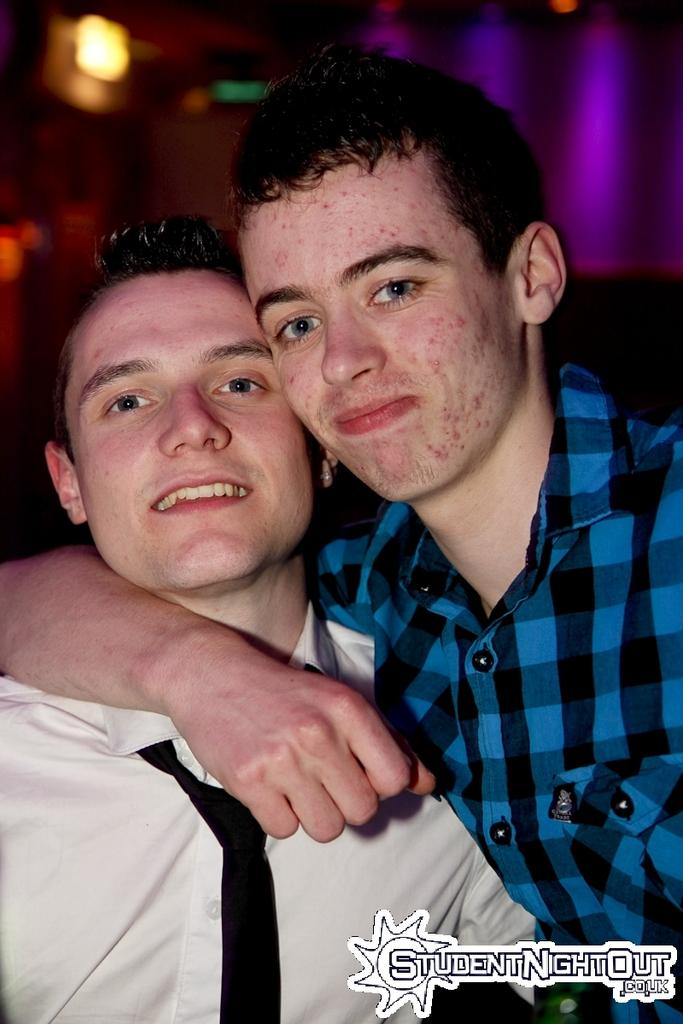How many men are in the image? There are two men in the image. What colors are the shirts worn by the men? The man on the right is wearing a blue shirt, and the man on the left is wearing a white shirt and a black tie. What can be seen in the background of the image? There are lights in the background of the image. What type of comb is the man on the left using in the image? There is no comb visible in the image, and therefore the man on the left is not using one. 